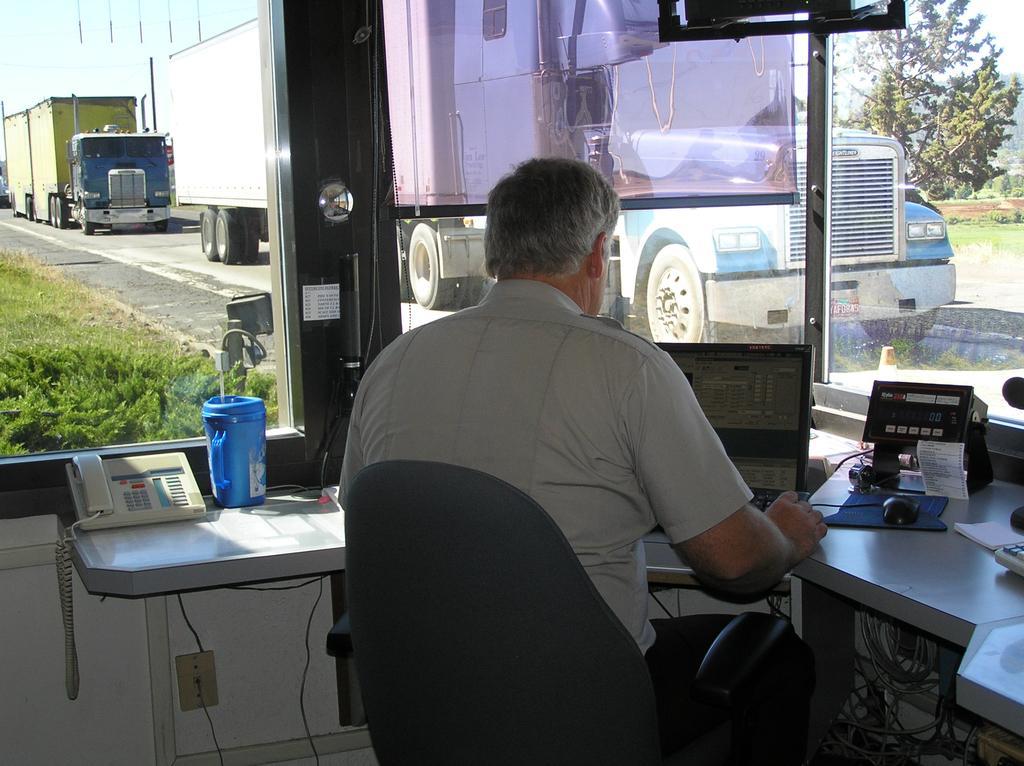Please provide a concise description of this image. In this picture we can see man sitting in chair and working on laptop beside to him there is a telephone, jug, some machine, mouse and here we see glass and from glass we can see vehicle, road, grass, tree. 